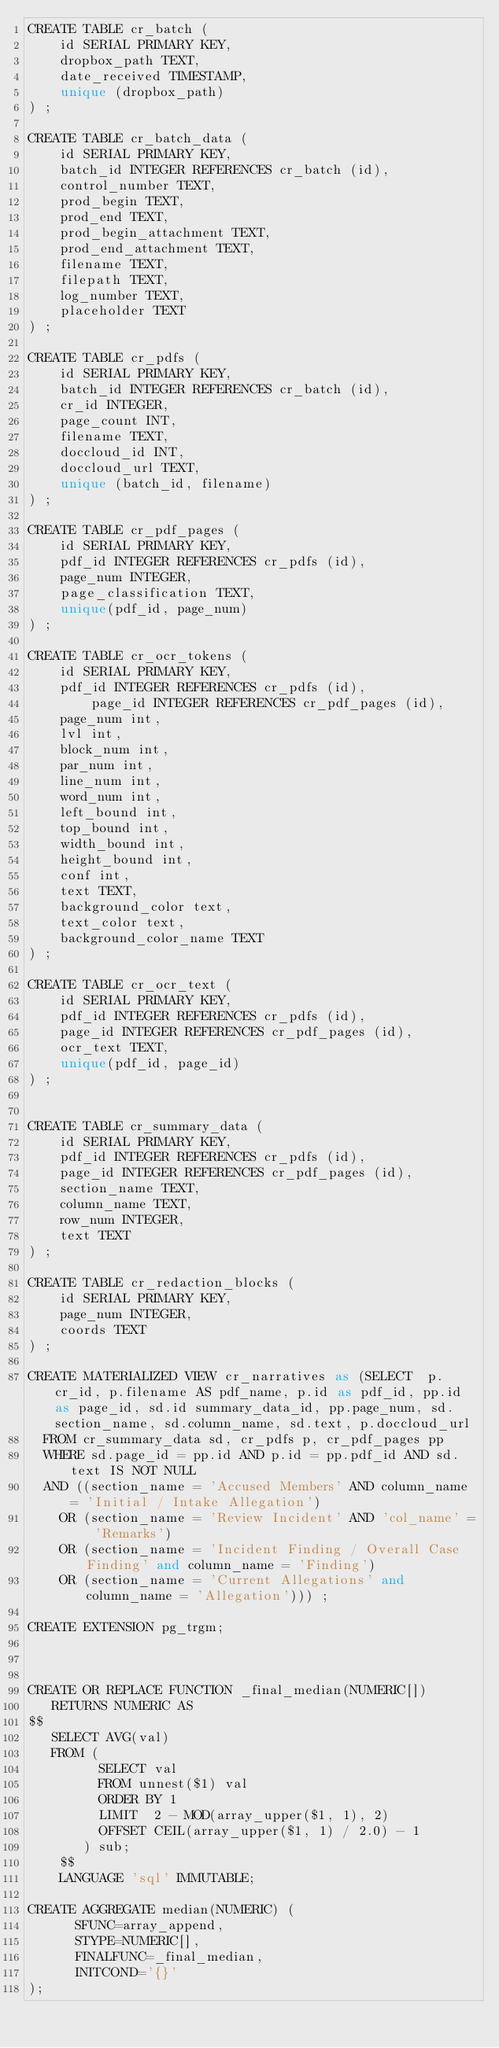<code> <loc_0><loc_0><loc_500><loc_500><_SQL_>CREATE TABLE cr_batch (
	id SERIAL PRIMARY KEY,
	dropbox_path TEXT,
	date_received TIMESTAMP,
	unique (dropbox_path)
) ;

CREATE TABLE cr_batch_data (
	id SERIAL PRIMARY KEY,
	batch_id INTEGER REFERENCES cr_batch (id),
	control_number TEXT,
	prod_begin TEXT,
	prod_end TEXT,
	prod_begin_attachment TEXT,
	prod_end_attachment TEXT,
	filename TEXT,
	filepath TEXT,
	log_number TEXT,
	placeholder TEXT
) ;

CREATE TABLE cr_pdfs (
	id SERIAL PRIMARY KEY,
	batch_id INTEGER REFERENCES cr_batch (id),
	cr_id INTEGER,
	page_count INT,
	filename TEXT,
	doccloud_id INT,
	doccloud_url TEXT,
	unique (batch_id, filename)
) ;

CREATE TABLE cr_pdf_pages (
	id SERIAL PRIMARY KEY,
	pdf_id INTEGER REFERENCES cr_pdfs (id),
	page_num INTEGER,
	page_classification TEXT,
	unique(pdf_id, page_num)
) ;

CREATE TABLE cr_ocr_tokens (
	id SERIAL PRIMARY KEY,
	pdf_id INTEGER REFERENCES cr_pdfs (id),
        page_id INTEGER REFERENCES cr_pdf_pages (id),
	page_num int,
	lvl int,
	block_num int,
	par_num int,
	line_num int,
	word_num int,
	left_bound int,
	top_bound int,
	width_bound int,
	height_bound int,
	conf int,
	text TEXT,
	background_color text,
	text_color text,
	background_color_name TEXT
) ;

CREATE TABLE cr_ocr_text (
    id SERIAL PRIMARY KEY,
    pdf_id INTEGER REFERENCES cr_pdfs (id),
    page_id INTEGER REFERENCES cr_pdf_pages (id),
    ocr_text TEXT,
    unique(pdf_id, page_id)
) ;


CREATE TABLE cr_summary_data (
    id SERIAL PRIMARY KEY,
    pdf_id INTEGER REFERENCES cr_pdfs (id),
    page_id INTEGER REFERENCES cr_pdf_pages (id),
    section_name TEXT,
    column_name TEXT,
    row_num INTEGER,
    text TEXT
) ;

CREATE TABLE cr_redaction_blocks (
    id SERIAL PRIMARY KEY,
    page_num INTEGER,
    coords TEXT
) ;

CREATE MATERIALIZED VIEW cr_narratives as (SELECT  p.cr_id, p.filename AS pdf_name, p.id as pdf_id, pp.id as page_id, sd.id summary_data_id, pp.page_num, sd.section_name, sd.column_name, sd.text, p.doccloud_url
  FROM cr_summary_data sd, cr_pdfs p, cr_pdf_pages pp
  WHERE sd.page_id = pp.id AND p.id = pp.pdf_id AND sd.text IS NOT NULL
  AND ((section_name = 'Accused Members' AND column_name = 'Initial / Intake Allegation')
    OR (section_name = 'Review Incident' AND 'col_name' = 'Remarks')
    OR (section_name = 'Incident Finding / Overall Case Finding' and column_name = 'Finding')
    OR (section_name = 'Current Allegations' and column_name = 'Allegation'))) ;

CREATE EXTENSION pg_trgm;



CREATE OR REPLACE FUNCTION _final_median(NUMERIC[])
   RETURNS NUMERIC AS
$$
   SELECT AVG(val)
   FROM (
	     SELECT val
	     FROM unnest($1) val
	     ORDER BY 1
	     LIMIT  2 - MOD(array_upper($1, 1), 2)
	     OFFSET CEIL(array_upper($1, 1) / 2.0) - 1
	   ) sub;
	$$
	LANGUAGE 'sql' IMMUTABLE;

CREATE AGGREGATE median(NUMERIC) (
	  SFUNC=array_append,
	  STYPE=NUMERIC[],
	  FINALFUNC=_final_median,
	  INITCOND='{}'
);
</code> 